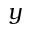<formula> <loc_0><loc_0><loc_500><loc_500>y</formula> 